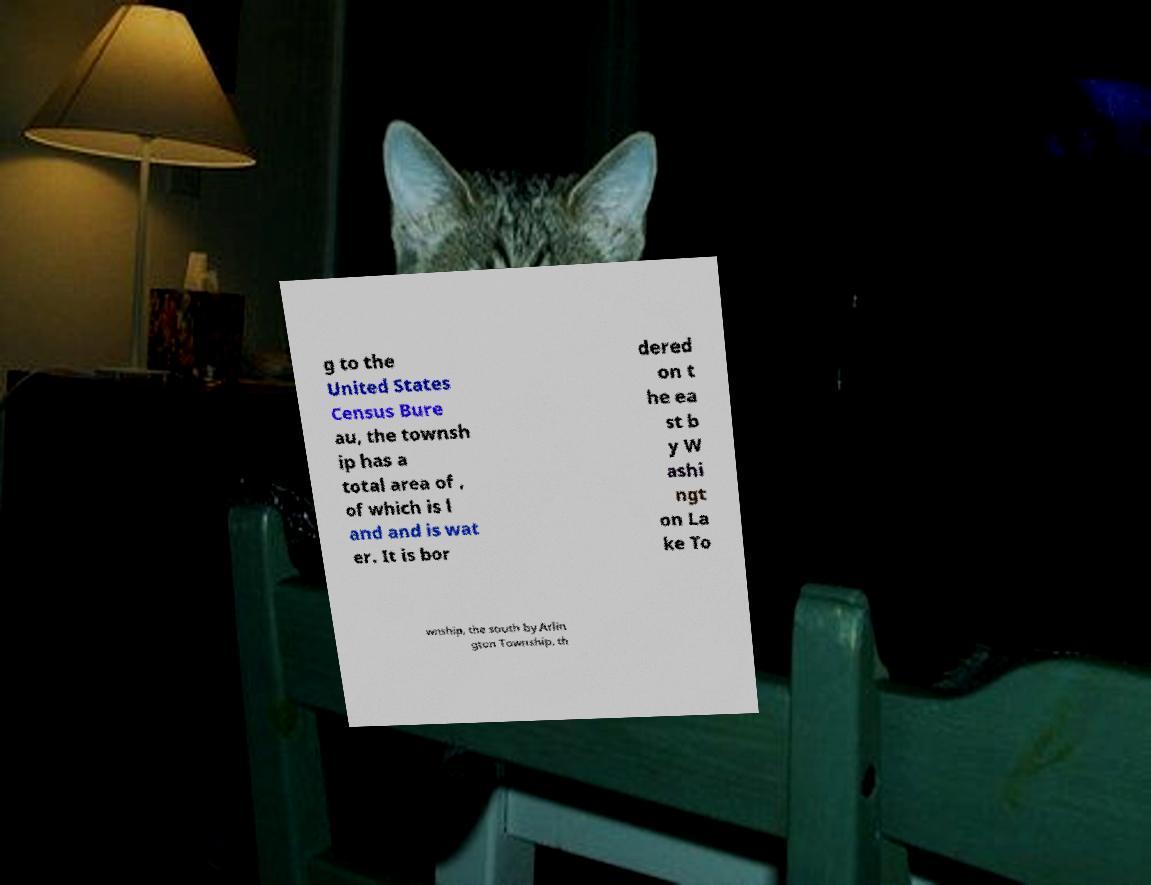Could you assist in decoding the text presented in this image and type it out clearly? g to the United States Census Bure au, the townsh ip has a total area of , of which is l and and is wat er. It is bor dered on t he ea st b y W ashi ngt on La ke To wnship, the south by Arlin gton Township, th 